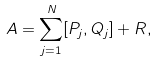Convert formula to latex. <formula><loc_0><loc_0><loc_500><loc_500>A = \sum _ { j = 1 } ^ { N } [ P _ { j } , Q _ { j } ] + R ,</formula> 